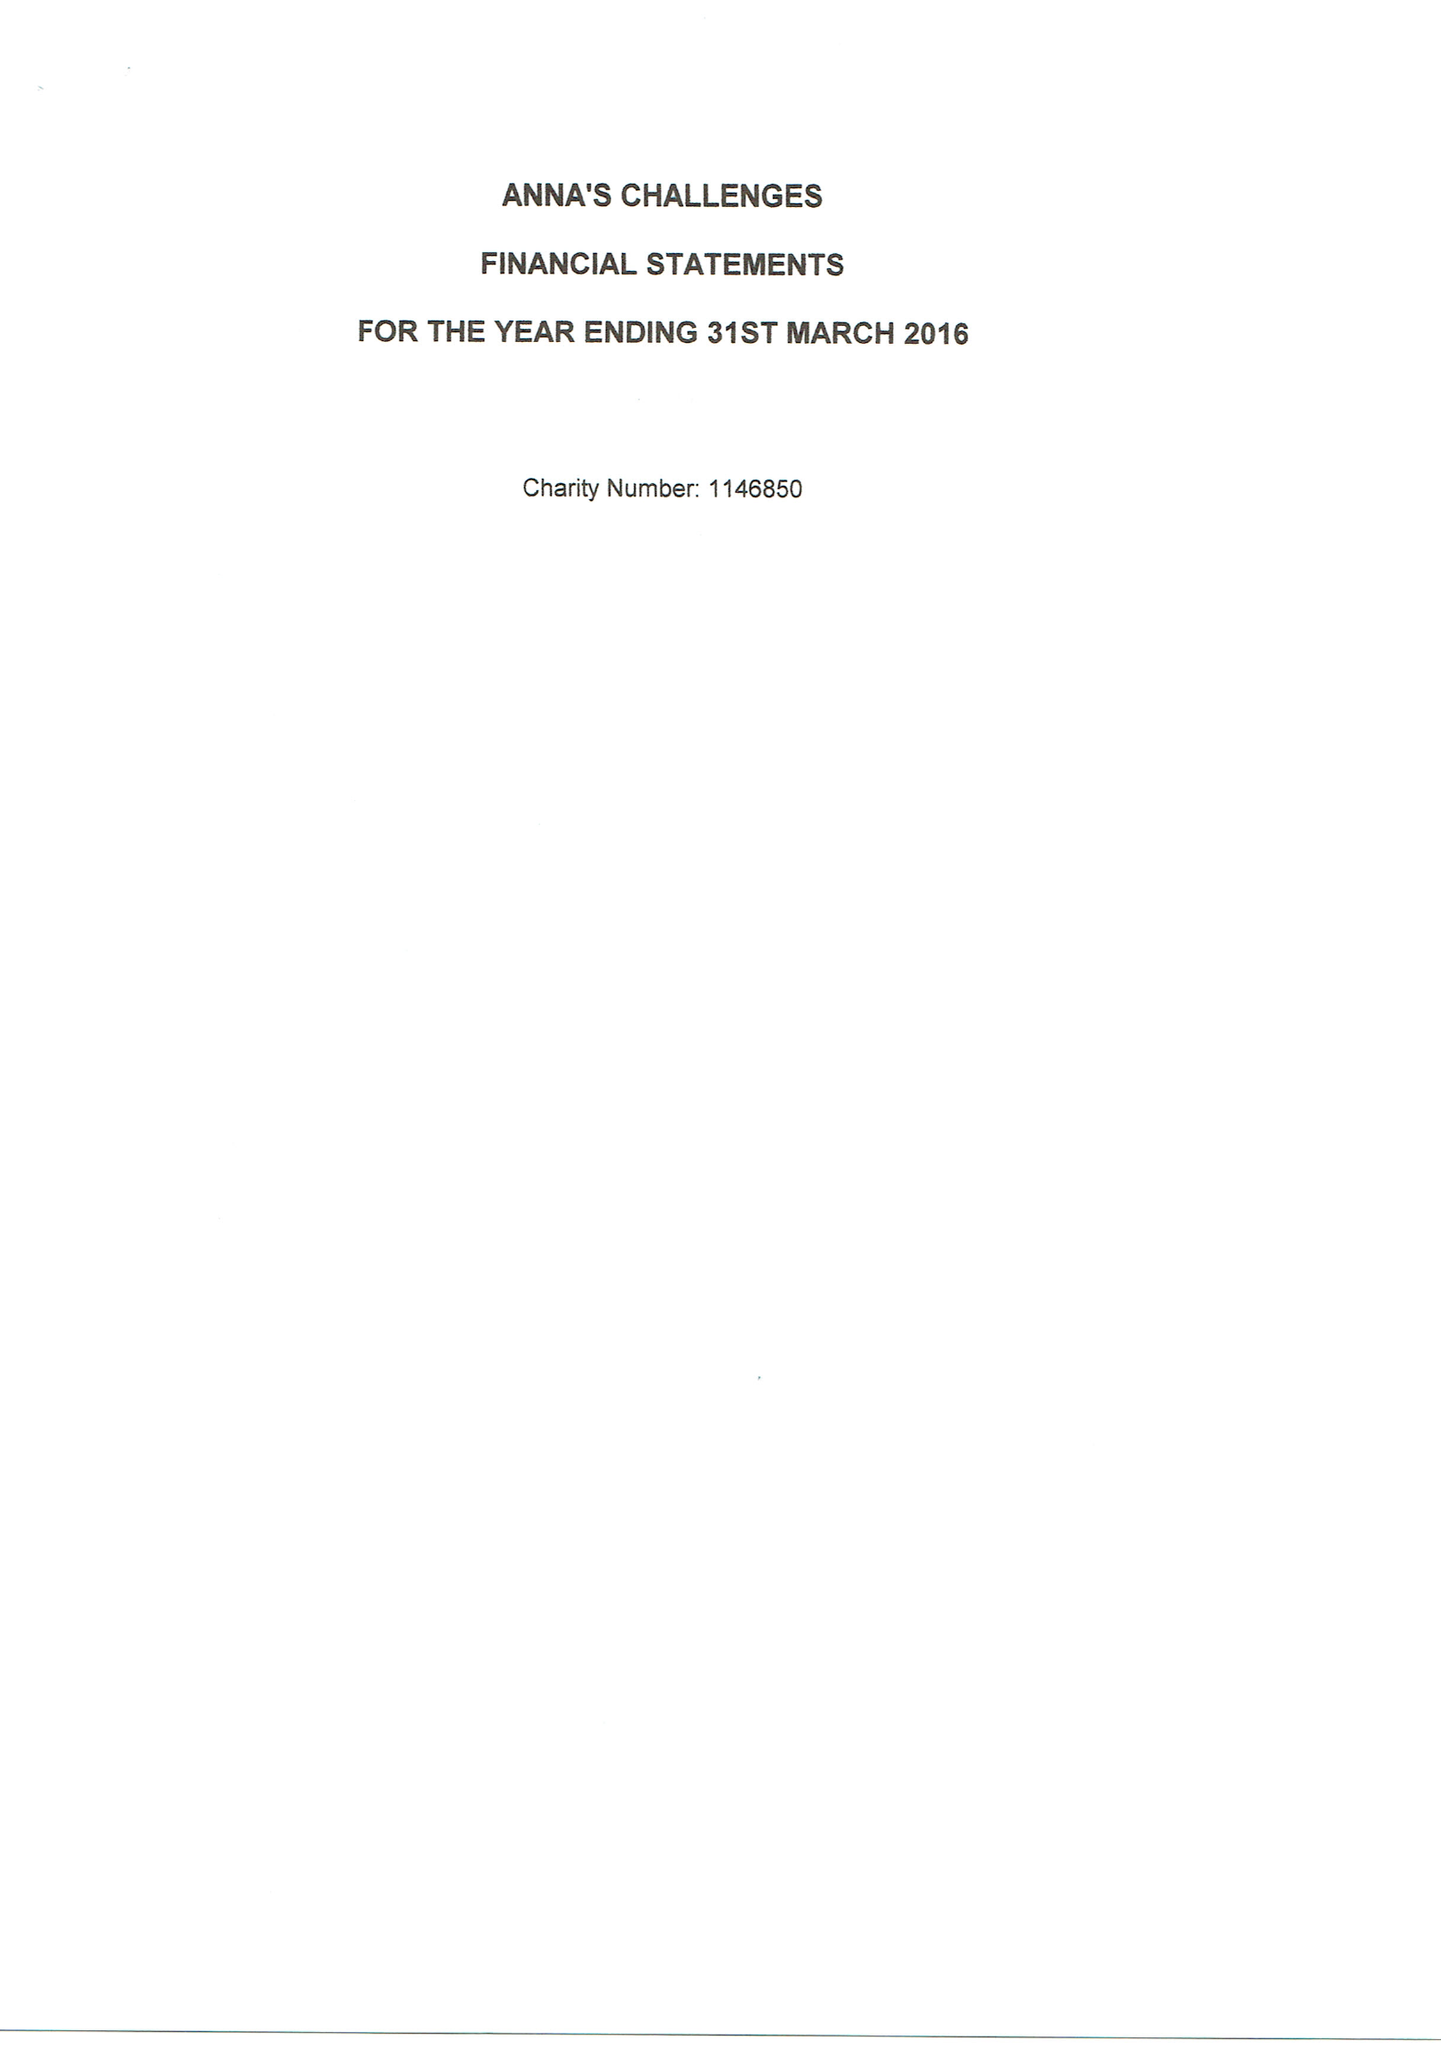What is the value for the address__street_line?
Answer the question using a single word or phrase. FORBURY ROAD 